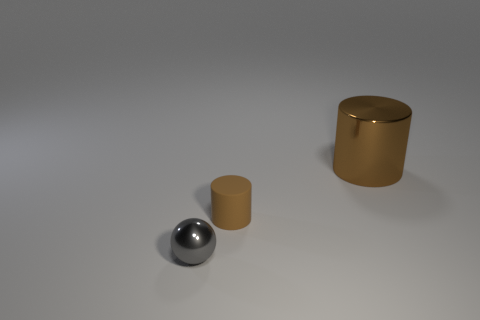Is there any other thing that has the same material as the small brown cylinder?
Make the answer very short. No. What number of small brown things have the same material as the tiny gray thing?
Make the answer very short. 0. Are there the same number of brown things to the left of the brown metal thing and spheres?
Your answer should be very brief. Yes. What is the material of the other big cylinder that is the same color as the matte cylinder?
Ensure brevity in your answer.  Metal. There is a gray metallic object; is it the same size as the brown thing that is in front of the large shiny thing?
Keep it short and to the point. Yes. What number of other objects are the same size as the metal sphere?
Provide a short and direct response. 1. How many other things are there of the same color as the small rubber cylinder?
Give a very brief answer. 1. Is there anything else that is the same size as the gray metal ball?
Your answer should be compact. Yes. How many other things are the same shape as the tiny brown rubber object?
Provide a succinct answer. 1. Do the rubber cylinder and the shiny sphere have the same size?
Your response must be concise. Yes. 